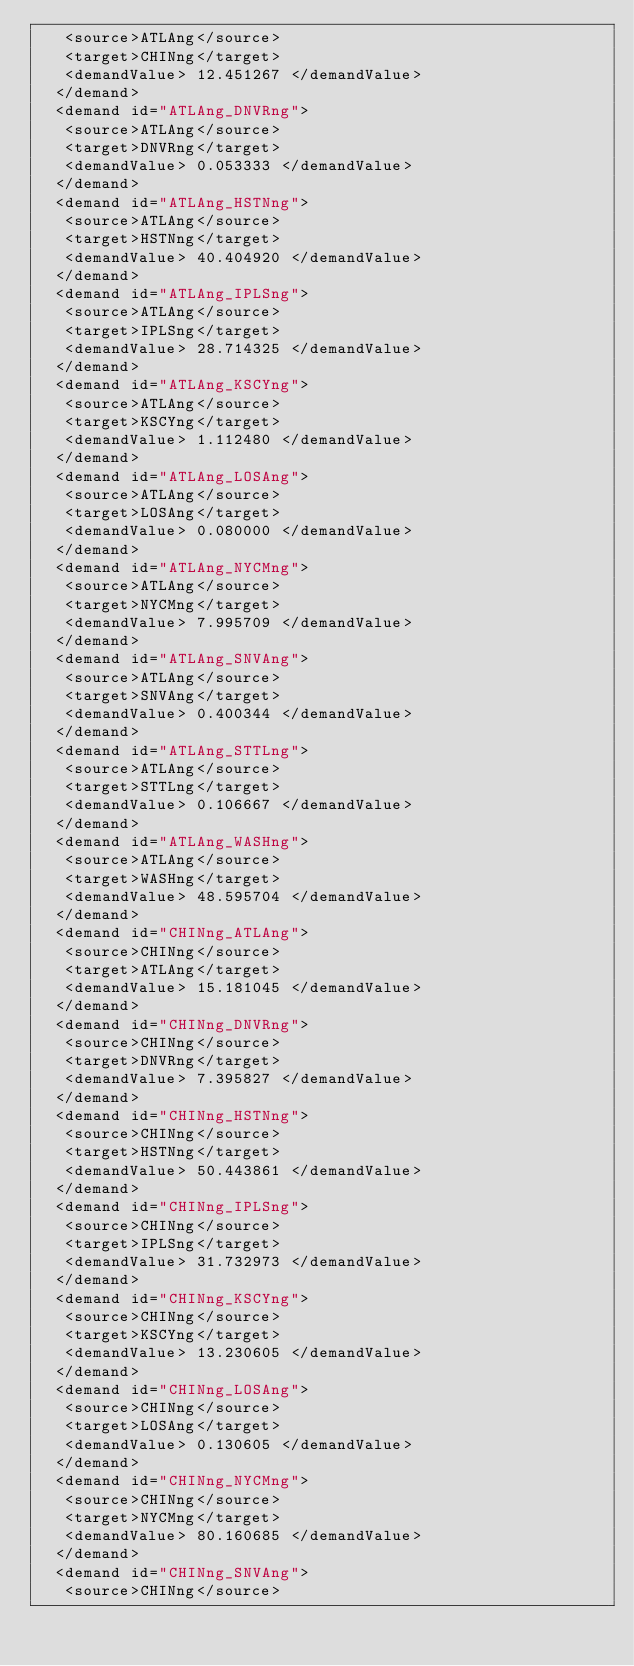Convert code to text. <code><loc_0><loc_0><loc_500><loc_500><_XML_>   <source>ATLAng</source>
   <target>CHINng</target>
   <demandValue> 12.451267 </demandValue>
  </demand>
  <demand id="ATLAng_DNVRng">
   <source>ATLAng</source>
   <target>DNVRng</target>
   <demandValue> 0.053333 </demandValue>
  </demand>
  <demand id="ATLAng_HSTNng">
   <source>ATLAng</source>
   <target>HSTNng</target>
   <demandValue> 40.404920 </demandValue>
  </demand>
  <demand id="ATLAng_IPLSng">
   <source>ATLAng</source>
   <target>IPLSng</target>
   <demandValue> 28.714325 </demandValue>
  </demand>
  <demand id="ATLAng_KSCYng">
   <source>ATLAng</source>
   <target>KSCYng</target>
   <demandValue> 1.112480 </demandValue>
  </demand>
  <demand id="ATLAng_LOSAng">
   <source>ATLAng</source>
   <target>LOSAng</target>
   <demandValue> 0.080000 </demandValue>
  </demand>
  <demand id="ATLAng_NYCMng">
   <source>ATLAng</source>
   <target>NYCMng</target>
   <demandValue> 7.995709 </demandValue>
  </demand>
  <demand id="ATLAng_SNVAng">
   <source>ATLAng</source>
   <target>SNVAng</target>
   <demandValue> 0.400344 </demandValue>
  </demand>
  <demand id="ATLAng_STTLng">
   <source>ATLAng</source>
   <target>STTLng</target>
   <demandValue> 0.106667 </demandValue>
  </demand>
  <demand id="ATLAng_WASHng">
   <source>ATLAng</source>
   <target>WASHng</target>
   <demandValue> 48.595704 </demandValue>
  </demand>
  <demand id="CHINng_ATLAng">
   <source>CHINng</source>
   <target>ATLAng</target>
   <demandValue> 15.181045 </demandValue>
  </demand>
  <demand id="CHINng_DNVRng">
   <source>CHINng</source>
   <target>DNVRng</target>
   <demandValue> 7.395827 </demandValue>
  </demand>
  <demand id="CHINng_HSTNng">
   <source>CHINng</source>
   <target>HSTNng</target>
   <demandValue> 50.443861 </demandValue>
  </demand>
  <demand id="CHINng_IPLSng">
   <source>CHINng</source>
   <target>IPLSng</target>
   <demandValue> 31.732973 </demandValue>
  </demand>
  <demand id="CHINng_KSCYng">
   <source>CHINng</source>
   <target>KSCYng</target>
   <demandValue> 13.230605 </demandValue>
  </demand>
  <demand id="CHINng_LOSAng">
   <source>CHINng</source>
   <target>LOSAng</target>
   <demandValue> 0.130605 </demandValue>
  </demand>
  <demand id="CHINng_NYCMng">
   <source>CHINng</source>
   <target>NYCMng</target>
   <demandValue> 80.160685 </demandValue>
  </demand>
  <demand id="CHINng_SNVAng">
   <source>CHINng</source></code> 